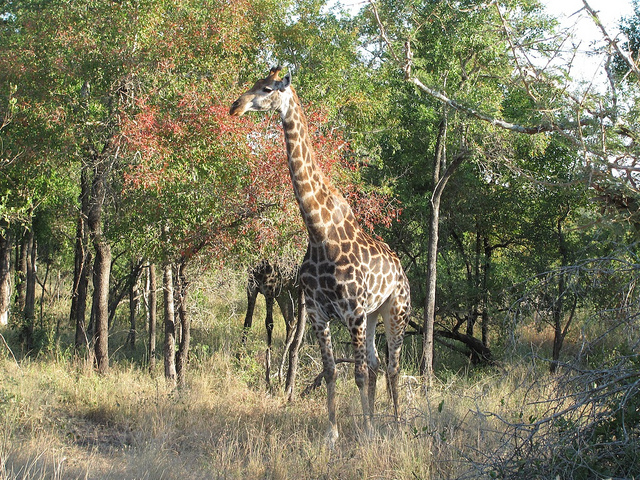What species of giraffe is shown in the picture? The giraffe in this image is difficult to identify to species level without a closer examination of its pattern and other physical characteristics. However, it resembles patterns typical of the Masai or Southern giraffe, species known for their irregular-shaped spots. 